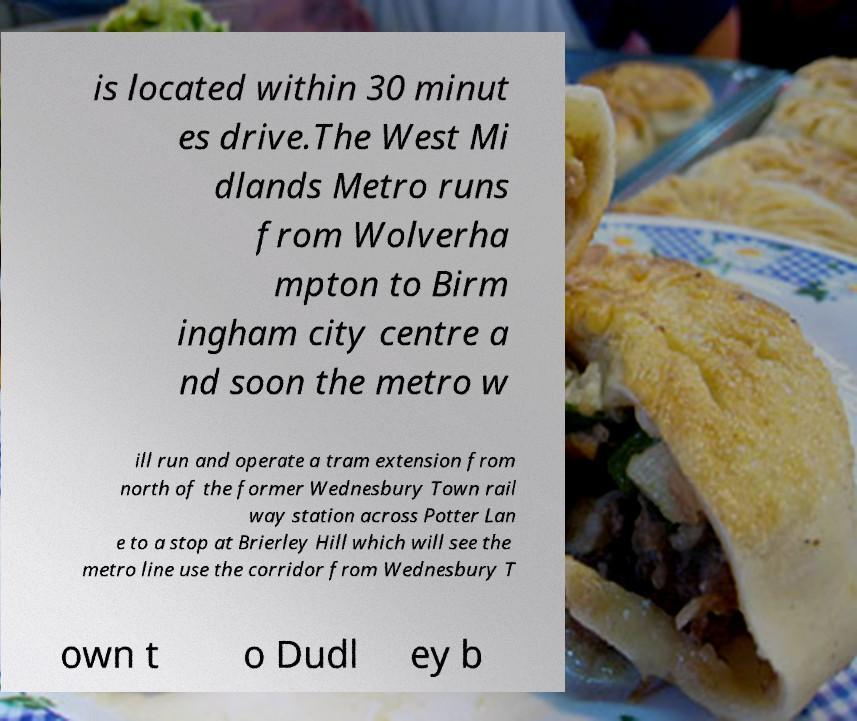There's text embedded in this image that I need extracted. Can you transcribe it verbatim? is located within 30 minut es drive.The West Mi dlands Metro runs from Wolverha mpton to Birm ingham city centre a nd soon the metro w ill run and operate a tram extension from north of the former Wednesbury Town rail way station across Potter Lan e to a stop at Brierley Hill which will see the metro line use the corridor from Wednesbury T own t o Dudl ey b 